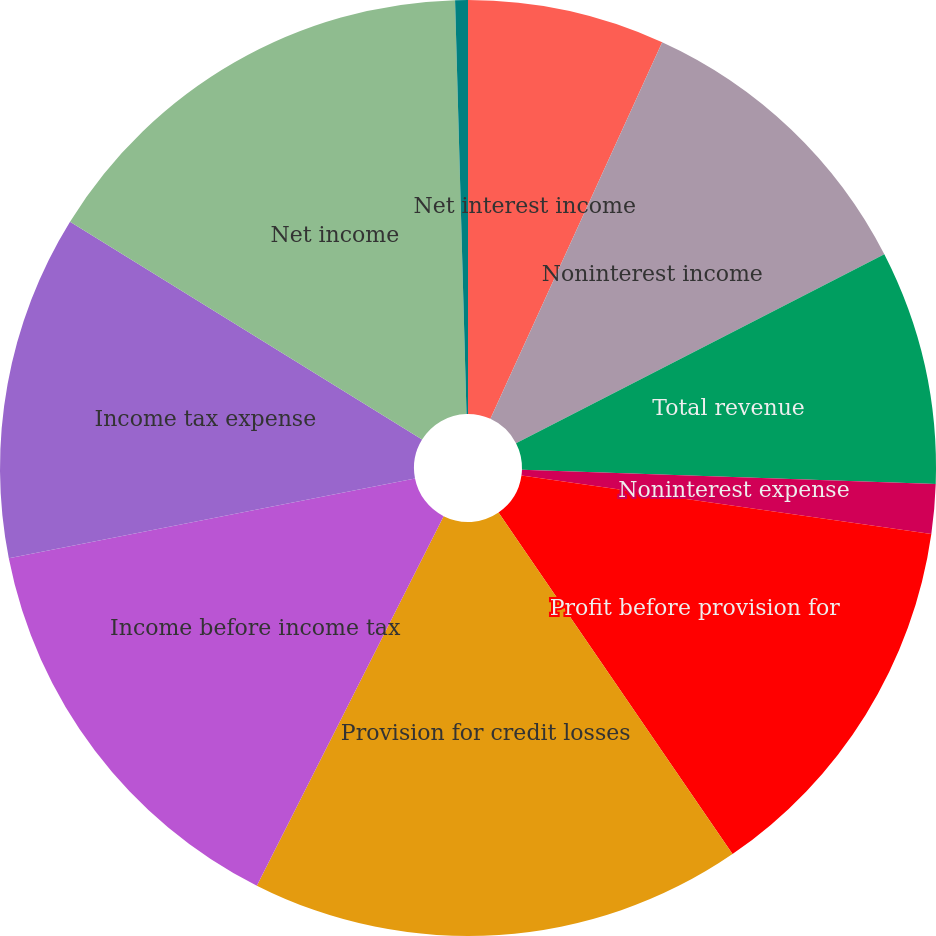<chart> <loc_0><loc_0><loc_500><loc_500><pie_chart><fcel>Net interest income<fcel>Noninterest income<fcel>Total revenue<fcel>Noninterest expense<fcel>Profit before provision for<fcel>Provision for credit losses<fcel>Income before income tax<fcel>Income tax expense<fcel>Net income<fcel>Loans and leases and loans<nl><fcel>6.81%<fcel>10.64%<fcel>8.09%<fcel>1.71%<fcel>13.19%<fcel>17.01%<fcel>14.46%<fcel>11.91%<fcel>15.74%<fcel>0.44%<nl></chart> 